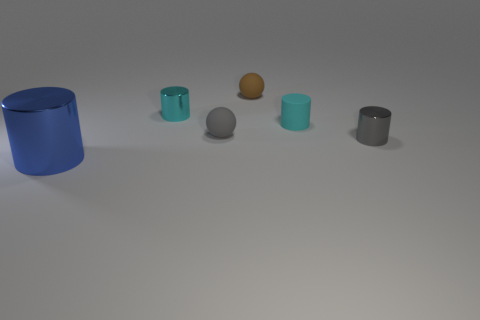How would you describe the lighting and shadows in the image? The lighting in the image is soft and diffused, creating gentle shadows that are cast to the right of the objects, indicating a light source to the left, outside of view. The shadows are soft-edged and elongated, hinting at a distant or large diffused light source, contributing to the calm and balanced atmosphere of the scene. 